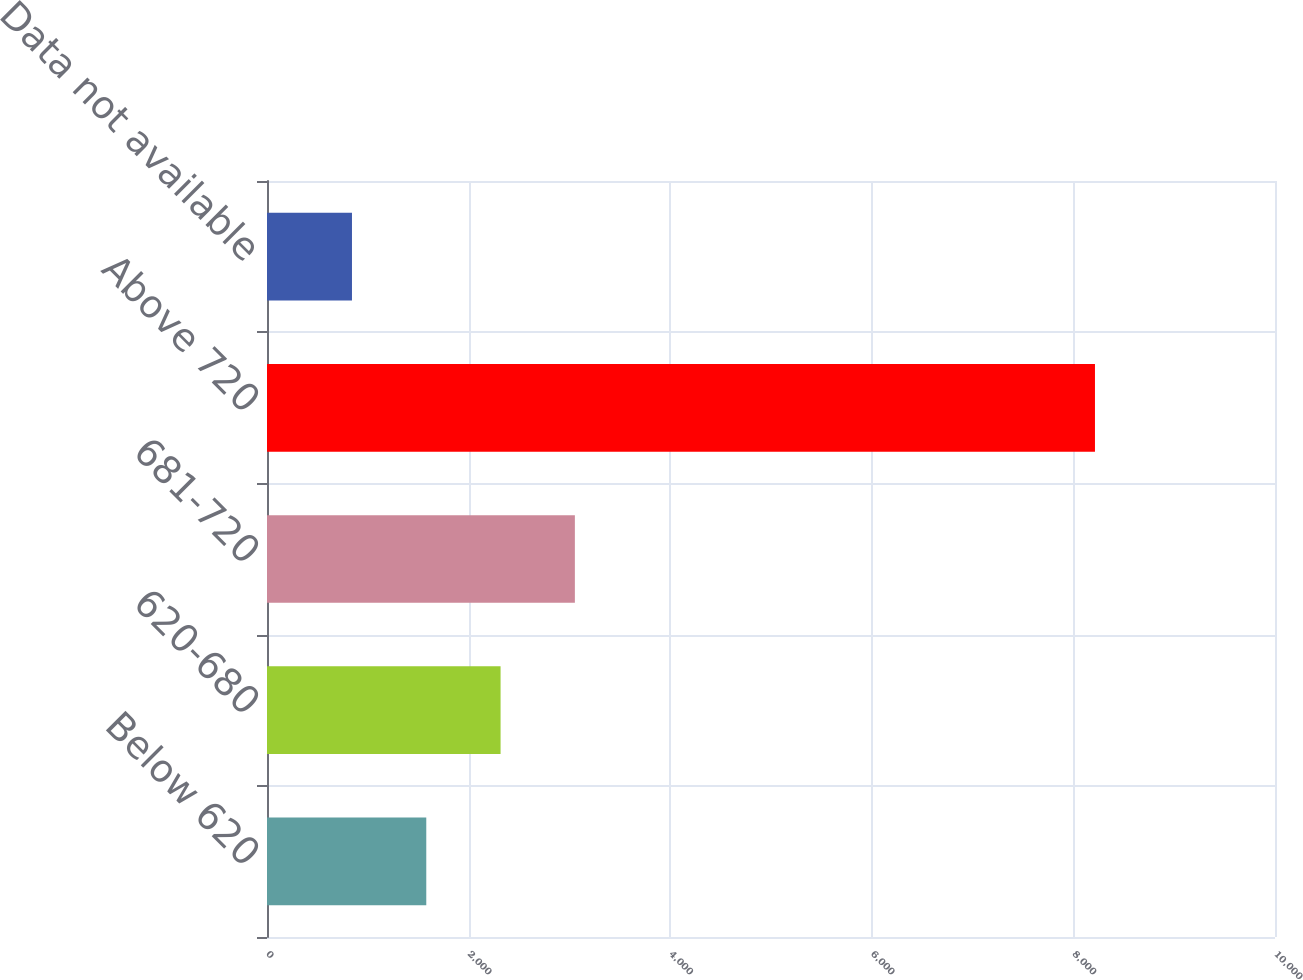Convert chart to OTSL. <chart><loc_0><loc_0><loc_500><loc_500><bar_chart><fcel>Below 620<fcel>620-680<fcel>681-720<fcel>Above 720<fcel>Data not available<nl><fcel>1580.1<fcel>2317.2<fcel>3054.3<fcel>8214<fcel>843<nl></chart> 